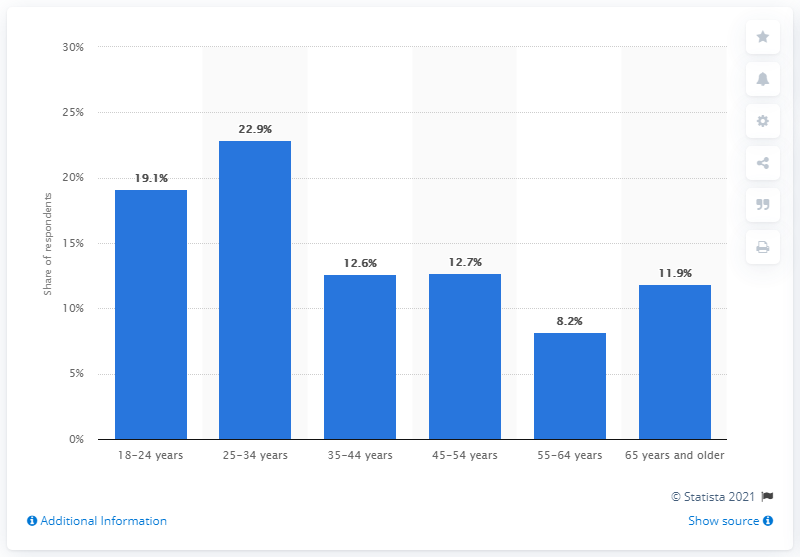Draw attention to some important aspects in this diagram. According to the data, approximately 22.9% of medical cannabis consumers fall within the age range of 25 to 34. 